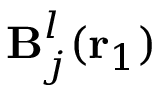<formula> <loc_0><loc_0><loc_500><loc_500>B _ { j } ^ { l } ( { r _ { 1 } } )</formula> 